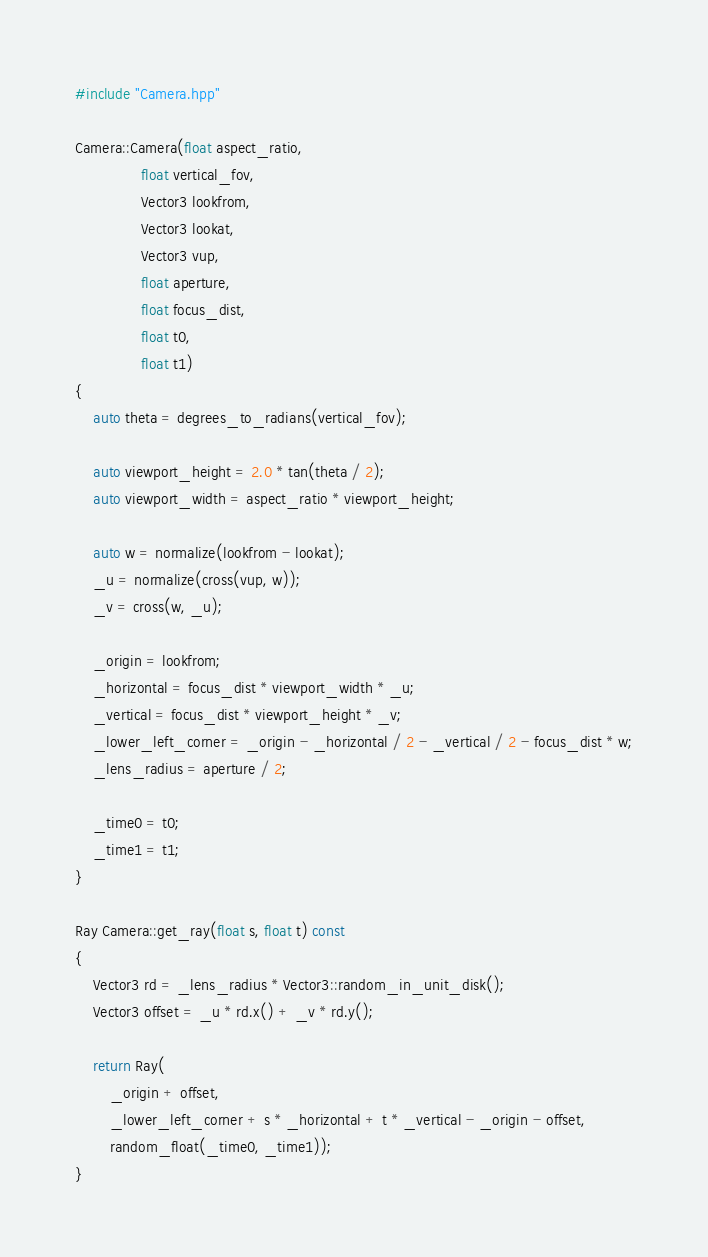<code> <loc_0><loc_0><loc_500><loc_500><_C++_>#include "Camera.hpp"

Camera::Camera(float aspect_ratio,
               float vertical_fov,
               Vector3 lookfrom,
               Vector3 lookat,
               Vector3 vup,
               float aperture,
               float focus_dist,
               float t0,
               float t1)
{
    auto theta = degrees_to_radians(vertical_fov);

    auto viewport_height = 2.0 * tan(theta / 2);
    auto viewport_width = aspect_ratio * viewport_height;

    auto w = normalize(lookfrom - lookat);
    _u = normalize(cross(vup, w));
    _v = cross(w, _u);

    _origin = lookfrom;
    _horizontal = focus_dist * viewport_width * _u;
    _vertical = focus_dist * viewport_height * _v;
    _lower_left_corner = _origin - _horizontal / 2 - _vertical / 2 - focus_dist * w;
    _lens_radius = aperture / 2;

    _time0 = t0;
    _time1 = t1;
}

Ray Camera::get_ray(float s, float t) const
{
    Vector3 rd = _lens_radius * Vector3::random_in_unit_disk();
    Vector3 offset = _u * rd.x() + _v * rd.y();

    return Ray(
        _origin + offset,
        _lower_left_corner + s * _horizontal + t * _vertical - _origin - offset,
        random_float(_time0, _time1));
}</code> 